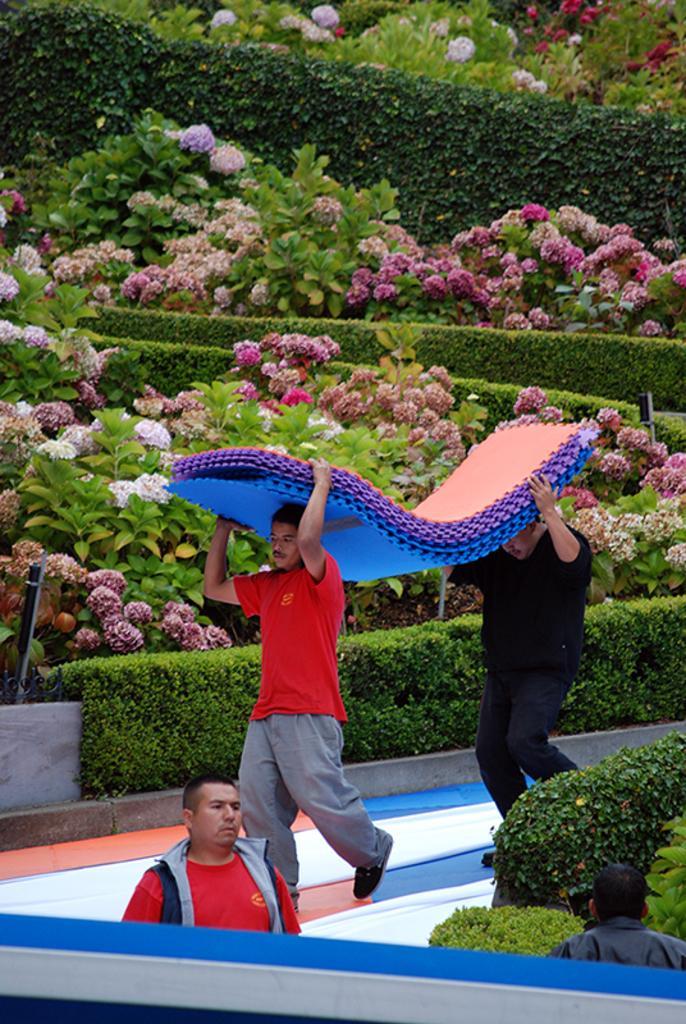Please provide a concise description of this image. In this image we can see two persons are carrying some rubber thing on there heads. Behind the garden is there with full of different color flowers. Bottom right of the image some plants are there and one person is present. To the left side of the image one person is there he is wearing black jacket with red t-shirt. 